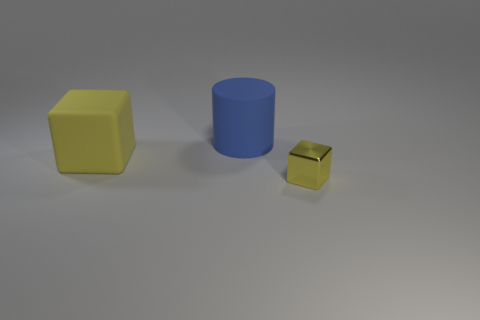Add 1 large brown cubes. How many objects exist? 4 Subtract all blocks. How many objects are left? 1 Subtract 0 purple blocks. How many objects are left? 3 Subtract all big blue cylinders. Subtract all yellow shiny cubes. How many objects are left? 1 Add 3 big cylinders. How many big cylinders are left? 4 Add 2 large brown metal spheres. How many large brown metal spheres exist? 2 